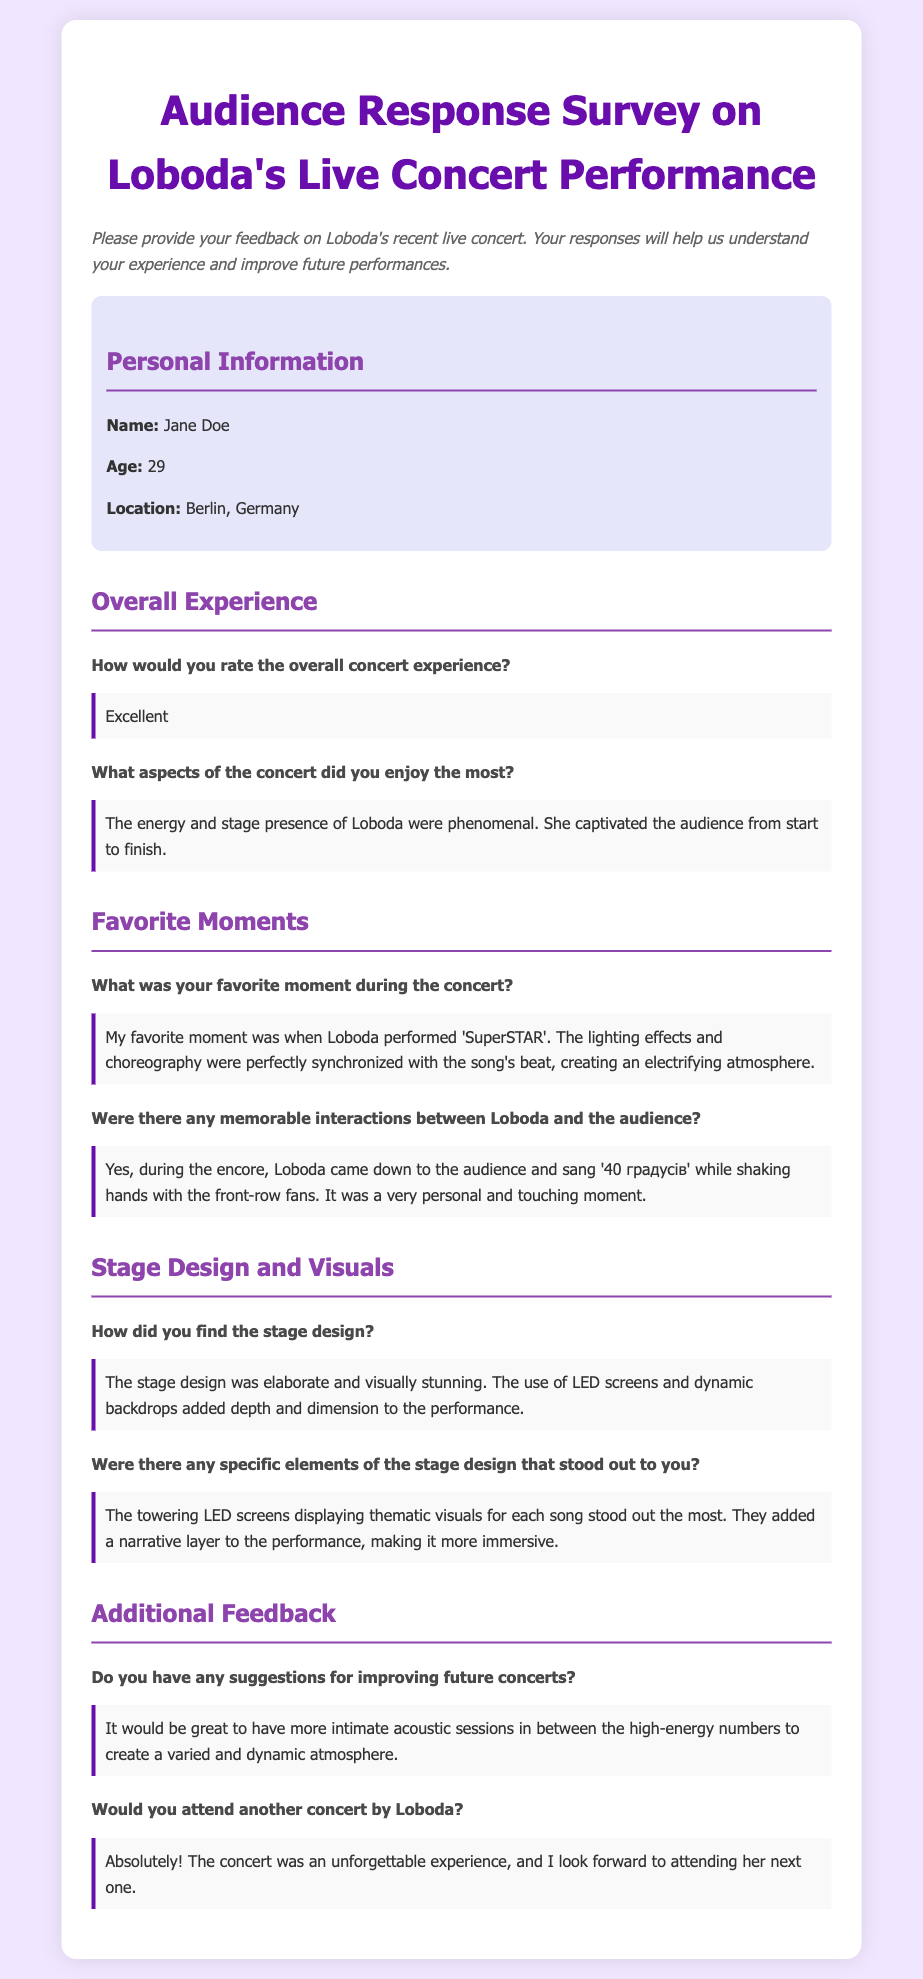How would you rate the overall concert experience? This is directly asked in the survey under Overall Experience, where the respondent provides their satisfaction level.
Answer: Excellent What was the favorite moment during the concert? The survey includes a question that invites the respondent to share their most memorable experience from the performance.
Answer: My favorite moment was when Loboda performed 'SuperSTAR' What was the age of the respondent? Personal information at the top of the document includes the respondent's age.
Answer: 29 What elements of stage design stood out to the respondent? The respondent was asked for specific elements they appreciated about the stage design, requiring a summary of their feedback.
Answer: The towering LED screens displaying thematic visuals for each song What suggestions does the respondent have for future concerts? The survey asks for any suggestions that could enhance future performances, which reveals the respondent's preferences.
Answer: It would be great to have more intimate acoustic sessions How did the respondent find the stage design? The question seeks the respondent's opinion on the overall stage design during the concert and is answered within the document.
Answer: The stage design was elaborate and visually stunning 